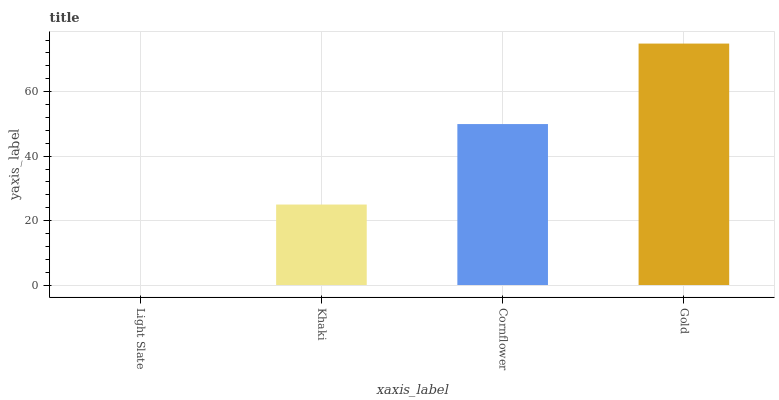Is Light Slate the minimum?
Answer yes or no. Yes. Is Gold the maximum?
Answer yes or no. Yes. Is Khaki the minimum?
Answer yes or no. No. Is Khaki the maximum?
Answer yes or no. No. Is Khaki greater than Light Slate?
Answer yes or no. Yes. Is Light Slate less than Khaki?
Answer yes or no. Yes. Is Light Slate greater than Khaki?
Answer yes or no. No. Is Khaki less than Light Slate?
Answer yes or no. No. Is Cornflower the high median?
Answer yes or no. Yes. Is Khaki the low median?
Answer yes or no. Yes. Is Gold the high median?
Answer yes or no. No. Is Light Slate the low median?
Answer yes or no. No. 